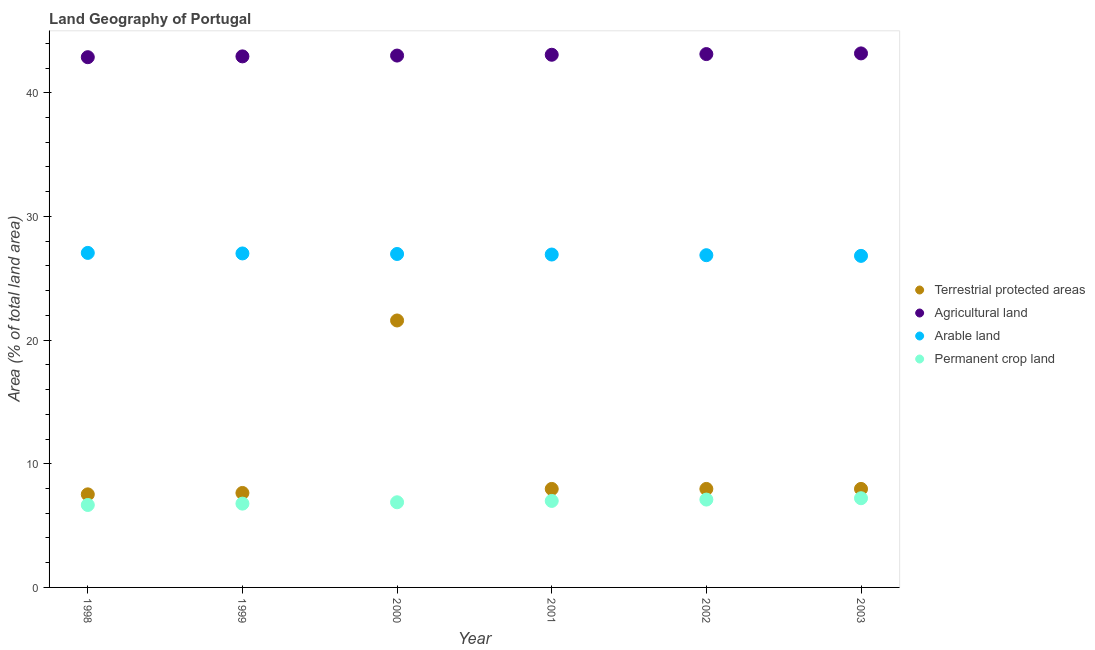Is the number of dotlines equal to the number of legend labels?
Ensure brevity in your answer.  Yes. What is the percentage of area under arable land in 1999?
Keep it short and to the point. 27.01. Across all years, what is the maximum percentage of area under permanent crop land?
Your response must be concise. 7.21. Across all years, what is the minimum percentage of land under terrestrial protection?
Provide a short and direct response. 7.53. In which year was the percentage of area under agricultural land minimum?
Keep it short and to the point. 1998. What is the total percentage of area under agricultural land in the graph?
Provide a succinct answer. 258.2. What is the difference between the percentage of land under terrestrial protection in 1998 and that in 2002?
Provide a succinct answer. -0.44. What is the difference between the percentage of area under permanent crop land in 1999 and the percentage of land under terrestrial protection in 2000?
Your answer should be very brief. -14.81. What is the average percentage of area under permanent crop land per year?
Offer a terse response. 6.94. In the year 2001, what is the difference between the percentage of area under agricultural land and percentage of area under arable land?
Your response must be concise. 16.15. What is the ratio of the percentage of area under agricultural land in 1998 to that in 1999?
Make the answer very short. 1. Is the percentage of area under agricultural land in 2000 less than that in 2002?
Offer a terse response. Yes. What is the difference between the highest and the second highest percentage of area under arable land?
Your response must be concise. 0.04. What is the difference between the highest and the lowest percentage of area under agricultural land?
Provide a short and direct response. 0.31. Is the sum of the percentage of area under permanent crop land in 1999 and 2002 greater than the maximum percentage of area under agricultural land across all years?
Your answer should be very brief. No. Is it the case that in every year, the sum of the percentage of area under agricultural land and percentage of area under permanent crop land is greater than the sum of percentage of land under terrestrial protection and percentage of area under arable land?
Give a very brief answer. Yes. How many years are there in the graph?
Your answer should be very brief. 6. Are the values on the major ticks of Y-axis written in scientific E-notation?
Your answer should be very brief. No. Does the graph contain any zero values?
Offer a very short reply. No. Does the graph contain grids?
Offer a very short reply. No. Where does the legend appear in the graph?
Give a very brief answer. Center right. How many legend labels are there?
Your answer should be very brief. 4. How are the legend labels stacked?
Your answer should be very brief. Vertical. What is the title of the graph?
Your answer should be very brief. Land Geography of Portugal. What is the label or title of the Y-axis?
Your response must be concise. Area (% of total land area). What is the Area (% of total land area) in Terrestrial protected areas in 1998?
Keep it short and to the point. 7.53. What is the Area (% of total land area) of Agricultural land in 1998?
Ensure brevity in your answer.  42.87. What is the Area (% of total land area) of Arable land in 1998?
Offer a terse response. 27.05. What is the Area (% of total land area) in Permanent crop land in 1998?
Ensure brevity in your answer.  6.67. What is the Area (% of total land area) in Terrestrial protected areas in 1999?
Ensure brevity in your answer.  7.64. What is the Area (% of total land area) of Agricultural land in 1999?
Give a very brief answer. 42.94. What is the Area (% of total land area) in Arable land in 1999?
Offer a very short reply. 27.01. What is the Area (% of total land area) of Permanent crop land in 1999?
Your response must be concise. 6.78. What is the Area (% of total land area) of Terrestrial protected areas in 2000?
Offer a very short reply. 21.59. What is the Area (% of total land area) in Agricultural land in 2000?
Make the answer very short. 43.01. What is the Area (% of total land area) of Arable land in 2000?
Provide a succinct answer. 26.96. What is the Area (% of total land area) in Permanent crop land in 2000?
Offer a very short reply. 6.89. What is the Area (% of total land area) in Terrestrial protected areas in 2001?
Your answer should be compact. 7.96. What is the Area (% of total land area) in Agricultural land in 2001?
Give a very brief answer. 43.07. What is the Area (% of total land area) in Arable land in 2001?
Provide a succinct answer. 26.92. What is the Area (% of total land area) in Permanent crop land in 2001?
Your answer should be compact. 6.99. What is the Area (% of total land area) in Terrestrial protected areas in 2002?
Offer a terse response. 7.96. What is the Area (% of total land area) of Agricultural land in 2002?
Offer a very short reply. 43.13. What is the Area (% of total land area) in Arable land in 2002?
Your answer should be compact. 26.86. What is the Area (% of total land area) of Permanent crop land in 2002?
Make the answer very short. 7.1. What is the Area (% of total land area) of Terrestrial protected areas in 2003?
Provide a succinct answer. 7.96. What is the Area (% of total land area) of Agricultural land in 2003?
Provide a short and direct response. 43.18. What is the Area (% of total land area) of Arable land in 2003?
Your answer should be very brief. 26.81. What is the Area (% of total land area) of Permanent crop land in 2003?
Give a very brief answer. 7.21. Across all years, what is the maximum Area (% of total land area) of Terrestrial protected areas?
Make the answer very short. 21.59. Across all years, what is the maximum Area (% of total land area) in Agricultural land?
Keep it short and to the point. 43.18. Across all years, what is the maximum Area (% of total land area) in Arable land?
Offer a very short reply. 27.05. Across all years, what is the maximum Area (% of total land area) in Permanent crop land?
Make the answer very short. 7.21. Across all years, what is the minimum Area (% of total land area) in Terrestrial protected areas?
Your response must be concise. 7.53. Across all years, what is the minimum Area (% of total land area) in Agricultural land?
Keep it short and to the point. 42.87. Across all years, what is the minimum Area (% of total land area) in Arable land?
Provide a short and direct response. 26.81. Across all years, what is the minimum Area (% of total land area) in Permanent crop land?
Your answer should be compact. 6.67. What is the total Area (% of total land area) in Terrestrial protected areas in the graph?
Give a very brief answer. 60.64. What is the total Area (% of total land area) in Agricultural land in the graph?
Make the answer very short. 258.2. What is the total Area (% of total land area) in Arable land in the graph?
Give a very brief answer. 161.61. What is the total Area (% of total land area) of Permanent crop land in the graph?
Your response must be concise. 41.64. What is the difference between the Area (% of total land area) of Terrestrial protected areas in 1998 and that in 1999?
Make the answer very short. -0.11. What is the difference between the Area (% of total land area) in Agricultural land in 1998 and that in 1999?
Your answer should be very brief. -0.07. What is the difference between the Area (% of total land area) in Arable land in 1998 and that in 1999?
Provide a short and direct response. 0.04. What is the difference between the Area (% of total land area) in Permanent crop land in 1998 and that in 1999?
Offer a very short reply. -0.11. What is the difference between the Area (% of total land area) in Terrestrial protected areas in 1998 and that in 2000?
Give a very brief answer. -14.06. What is the difference between the Area (% of total land area) in Agricultural land in 1998 and that in 2000?
Make the answer very short. -0.13. What is the difference between the Area (% of total land area) in Arable land in 1998 and that in 2000?
Make the answer very short. 0.09. What is the difference between the Area (% of total land area) of Permanent crop land in 1998 and that in 2000?
Offer a very short reply. -0.22. What is the difference between the Area (% of total land area) of Terrestrial protected areas in 1998 and that in 2001?
Your response must be concise. -0.44. What is the difference between the Area (% of total land area) in Agricultural land in 1998 and that in 2001?
Provide a succinct answer. -0.2. What is the difference between the Area (% of total land area) of Arable land in 1998 and that in 2001?
Keep it short and to the point. 0.13. What is the difference between the Area (% of total land area) in Permanent crop land in 1998 and that in 2001?
Your answer should be compact. -0.33. What is the difference between the Area (% of total land area) in Terrestrial protected areas in 1998 and that in 2002?
Keep it short and to the point. -0.44. What is the difference between the Area (% of total land area) of Agricultural land in 1998 and that in 2002?
Provide a short and direct response. -0.25. What is the difference between the Area (% of total land area) of Arable land in 1998 and that in 2002?
Keep it short and to the point. 0.19. What is the difference between the Area (% of total land area) of Permanent crop land in 1998 and that in 2002?
Provide a succinct answer. -0.44. What is the difference between the Area (% of total land area) of Terrestrial protected areas in 1998 and that in 2003?
Your answer should be compact. -0.44. What is the difference between the Area (% of total land area) of Agricultural land in 1998 and that in 2003?
Provide a succinct answer. -0.31. What is the difference between the Area (% of total land area) in Arable land in 1998 and that in 2003?
Keep it short and to the point. 0.24. What is the difference between the Area (% of total land area) of Permanent crop land in 1998 and that in 2003?
Ensure brevity in your answer.  -0.55. What is the difference between the Area (% of total land area) in Terrestrial protected areas in 1999 and that in 2000?
Make the answer very short. -13.95. What is the difference between the Area (% of total land area) in Agricultural land in 1999 and that in 2000?
Provide a succinct answer. -0.07. What is the difference between the Area (% of total land area) in Arable land in 1999 and that in 2000?
Offer a very short reply. 0.04. What is the difference between the Area (% of total land area) of Permanent crop land in 1999 and that in 2000?
Ensure brevity in your answer.  -0.11. What is the difference between the Area (% of total land area) in Terrestrial protected areas in 1999 and that in 2001?
Offer a terse response. -0.33. What is the difference between the Area (% of total land area) in Agricultural land in 1999 and that in 2001?
Give a very brief answer. -0.13. What is the difference between the Area (% of total land area) in Arable land in 1999 and that in 2001?
Offer a terse response. 0.09. What is the difference between the Area (% of total land area) in Permanent crop land in 1999 and that in 2001?
Your answer should be very brief. -0.22. What is the difference between the Area (% of total land area) in Terrestrial protected areas in 1999 and that in 2002?
Offer a very short reply. -0.33. What is the difference between the Area (% of total land area) in Agricultural land in 1999 and that in 2002?
Make the answer very short. -0.19. What is the difference between the Area (% of total land area) of Arable land in 1999 and that in 2002?
Provide a succinct answer. 0.14. What is the difference between the Area (% of total land area) of Permanent crop land in 1999 and that in 2002?
Provide a succinct answer. -0.33. What is the difference between the Area (% of total land area) of Terrestrial protected areas in 1999 and that in 2003?
Your response must be concise. -0.33. What is the difference between the Area (% of total land area) of Agricultural land in 1999 and that in 2003?
Provide a short and direct response. -0.24. What is the difference between the Area (% of total land area) in Arable land in 1999 and that in 2003?
Provide a succinct answer. 0.2. What is the difference between the Area (% of total land area) in Permanent crop land in 1999 and that in 2003?
Offer a terse response. -0.44. What is the difference between the Area (% of total land area) of Terrestrial protected areas in 2000 and that in 2001?
Keep it short and to the point. 13.62. What is the difference between the Area (% of total land area) of Agricultural land in 2000 and that in 2001?
Offer a terse response. -0.07. What is the difference between the Area (% of total land area) of Arable land in 2000 and that in 2001?
Give a very brief answer. 0.04. What is the difference between the Area (% of total land area) in Permanent crop land in 2000 and that in 2001?
Your answer should be compact. -0.11. What is the difference between the Area (% of total land area) of Terrestrial protected areas in 2000 and that in 2002?
Offer a terse response. 13.62. What is the difference between the Area (% of total land area) of Agricultural land in 2000 and that in 2002?
Your answer should be very brief. -0.12. What is the difference between the Area (% of total land area) in Arable land in 2000 and that in 2002?
Make the answer very short. 0.1. What is the difference between the Area (% of total land area) in Permanent crop land in 2000 and that in 2002?
Provide a short and direct response. -0.22. What is the difference between the Area (% of total land area) in Terrestrial protected areas in 2000 and that in 2003?
Ensure brevity in your answer.  13.62. What is the difference between the Area (% of total land area) in Agricultural land in 2000 and that in 2003?
Your answer should be compact. -0.17. What is the difference between the Area (% of total land area) of Arable land in 2000 and that in 2003?
Provide a succinct answer. 0.15. What is the difference between the Area (% of total land area) in Permanent crop land in 2000 and that in 2003?
Keep it short and to the point. -0.33. What is the difference between the Area (% of total land area) in Terrestrial protected areas in 2001 and that in 2002?
Your answer should be very brief. 0. What is the difference between the Area (% of total land area) of Agricultural land in 2001 and that in 2002?
Provide a succinct answer. -0.05. What is the difference between the Area (% of total land area) of Arable land in 2001 and that in 2002?
Ensure brevity in your answer.  0.05. What is the difference between the Area (% of total land area) in Permanent crop land in 2001 and that in 2002?
Ensure brevity in your answer.  -0.11. What is the difference between the Area (% of total land area) of Agricultural land in 2001 and that in 2003?
Your answer should be compact. -0.11. What is the difference between the Area (% of total land area) of Arable land in 2001 and that in 2003?
Offer a very short reply. 0.11. What is the difference between the Area (% of total land area) in Permanent crop land in 2001 and that in 2003?
Make the answer very short. -0.22. What is the difference between the Area (% of total land area) of Terrestrial protected areas in 2002 and that in 2003?
Give a very brief answer. 0. What is the difference between the Area (% of total land area) in Agricultural land in 2002 and that in 2003?
Keep it short and to the point. -0.05. What is the difference between the Area (% of total land area) in Arable land in 2002 and that in 2003?
Provide a short and direct response. 0.05. What is the difference between the Area (% of total land area) of Permanent crop land in 2002 and that in 2003?
Keep it short and to the point. -0.11. What is the difference between the Area (% of total land area) in Terrestrial protected areas in 1998 and the Area (% of total land area) in Agricultural land in 1999?
Your answer should be very brief. -35.41. What is the difference between the Area (% of total land area) of Terrestrial protected areas in 1998 and the Area (% of total land area) of Arable land in 1999?
Make the answer very short. -19.48. What is the difference between the Area (% of total land area) of Terrestrial protected areas in 1998 and the Area (% of total land area) of Permanent crop land in 1999?
Provide a succinct answer. 0.75. What is the difference between the Area (% of total land area) in Agricultural land in 1998 and the Area (% of total land area) in Arable land in 1999?
Ensure brevity in your answer.  15.87. What is the difference between the Area (% of total land area) in Agricultural land in 1998 and the Area (% of total land area) in Permanent crop land in 1999?
Keep it short and to the point. 36.1. What is the difference between the Area (% of total land area) in Arable land in 1998 and the Area (% of total land area) in Permanent crop land in 1999?
Your answer should be compact. 20.27. What is the difference between the Area (% of total land area) of Terrestrial protected areas in 1998 and the Area (% of total land area) of Agricultural land in 2000?
Your answer should be compact. -35.48. What is the difference between the Area (% of total land area) in Terrestrial protected areas in 1998 and the Area (% of total land area) in Arable land in 2000?
Your response must be concise. -19.44. What is the difference between the Area (% of total land area) in Terrestrial protected areas in 1998 and the Area (% of total land area) in Permanent crop land in 2000?
Provide a short and direct response. 0.64. What is the difference between the Area (% of total land area) of Agricultural land in 1998 and the Area (% of total land area) of Arable land in 2000?
Your answer should be very brief. 15.91. What is the difference between the Area (% of total land area) of Agricultural land in 1998 and the Area (% of total land area) of Permanent crop land in 2000?
Provide a succinct answer. 35.99. What is the difference between the Area (% of total land area) in Arable land in 1998 and the Area (% of total land area) in Permanent crop land in 2000?
Your answer should be compact. 20.16. What is the difference between the Area (% of total land area) in Terrestrial protected areas in 1998 and the Area (% of total land area) in Agricultural land in 2001?
Provide a short and direct response. -35.55. What is the difference between the Area (% of total land area) in Terrestrial protected areas in 1998 and the Area (% of total land area) in Arable land in 2001?
Make the answer very short. -19.39. What is the difference between the Area (% of total land area) of Terrestrial protected areas in 1998 and the Area (% of total land area) of Permanent crop land in 2001?
Provide a succinct answer. 0.53. What is the difference between the Area (% of total land area) in Agricultural land in 1998 and the Area (% of total land area) in Arable land in 2001?
Give a very brief answer. 15.96. What is the difference between the Area (% of total land area) in Agricultural land in 1998 and the Area (% of total land area) in Permanent crop land in 2001?
Keep it short and to the point. 35.88. What is the difference between the Area (% of total land area) of Arable land in 1998 and the Area (% of total land area) of Permanent crop land in 2001?
Keep it short and to the point. 20.05. What is the difference between the Area (% of total land area) in Terrestrial protected areas in 1998 and the Area (% of total land area) in Agricultural land in 2002?
Keep it short and to the point. -35.6. What is the difference between the Area (% of total land area) in Terrestrial protected areas in 1998 and the Area (% of total land area) in Arable land in 2002?
Keep it short and to the point. -19.34. What is the difference between the Area (% of total land area) in Terrestrial protected areas in 1998 and the Area (% of total land area) in Permanent crop land in 2002?
Your answer should be compact. 0.42. What is the difference between the Area (% of total land area) of Agricultural land in 1998 and the Area (% of total land area) of Arable land in 2002?
Your answer should be very brief. 16.01. What is the difference between the Area (% of total land area) in Agricultural land in 1998 and the Area (% of total land area) in Permanent crop land in 2002?
Offer a terse response. 35.77. What is the difference between the Area (% of total land area) in Arable land in 1998 and the Area (% of total land area) in Permanent crop land in 2002?
Make the answer very short. 19.95. What is the difference between the Area (% of total land area) in Terrestrial protected areas in 1998 and the Area (% of total land area) in Agricultural land in 2003?
Keep it short and to the point. -35.65. What is the difference between the Area (% of total land area) of Terrestrial protected areas in 1998 and the Area (% of total land area) of Arable land in 2003?
Make the answer very short. -19.28. What is the difference between the Area (% of total land area) in Terrestrial protected areas in 1998 and the Area (% of total land area) in Permanent crop land in 2003?
Ensure brevity in your answer.  0.31. What is the difference between the Area (% of total land area) in Agricultural land in 1998 and the Area (% of total land area) in Arable land in 2003?
Make the answer very short. 16.07. What is the difference between the Area (% of total land area) in Agricultural land in 1998 and the Area (% of total land area) in Permanent crop land in 2003?
Make the answer very short. 35.66. What is the difference between the Area (% of total land area) of Arable land in 1998 and the Area (% of total land area) of Permanent crop land in 2003?
Provide a succinct answer. 19.84. What is the difference between the Area (% of total land area) in Terrestrial protected areas in 1999 and the Area (% of total land area) in Agricultural land in 2000?
Offer a very short reply. -35.37. What is the difference between the Area (% of total land area) in Terrestrial protected areas in 1999 and the Area (% of total land area) in Arable land in 2000?
Provide a succinct answer. -19.32. What is the difference between the Area (% of total land area) of Terrestrial protected areas in 1999 and the Area (% of total land area) of Permanent crop land in 2000?
Keep it short and to the point. 0.75. What is the difference between the Area (% of total land area) in Agricultural land in 1999 and the Area (% of total land area) in Arable land in 2000?
Provide a succinct answer. 15.98. What is the difference between the Area (% of total land area) of Agricultural land in 1999 and the Area (% of total land area) of Permanent crop land in 2000?
Ensure brevity in your answer.  36.05. What is the difference between the Area (% of total land area) of Arable land in 1999 and the Area (% of total land area) of Permanent crop land in 2000?
Make the answer very short. 20.12. What is the difference between the Area (% of total land area) of Terrestrial protected areas in 1999 and the Area (% of total land area) of Agricultural land in 2001?
Provide a succinct answer. -35.43. What is the difference between the Area (% of total land area) of Terrestrial protected areas in 1999 and the Area (% of total land area) of Arable land in 2001?
Offer a terse response. -19.28. What is the difference between the Area (% of total land area) in Terrestrial protected areas in 1999 and the Area (% of total land area) in Permanent crop land in 2001?
Provide a succinct answer. 0.64. What is the difference between the Area (% of total land area) in Agricultural land in 1999 and the Area (% of total land area) in Arable land in 2001?
Offer a terse response. 16.02. What is the difference between the Area (% of total land area) in Agricultural land in 1999 and the Area (% of total land area) in Permanent crop land in 2001?
Give a very brief answer. 35.95. What is the difference between the Area (% of total land area) in Arable land in 1999 and the Area (% of total land area) in Permanent crop land in 2001?
Your answer should be very brief. 20.01. What is the difference between the Area (% of total land area) in Terrestrial protected areas in 1999 and the Area (% of total land area) in Agricultural land in 2002?
Your answer should be compact. -35.49. What is the difference between the Area (% of total land area) of Terrestrial protected areas in 1999 and the Area (% of total land area) of Arable land in 2002?
Give a very brief answer. -19.23. What is the difference between the Area (% of total land area) of Terrestrial protected areas in 1999 and the Area (% of total land area) of Permanent crop land in 2002?
Ensure brevity in your answer.  0.53. What is the difference between the Area (% of total land area) of Agricultural land in 1999 and the Area (% of total land area) of Arable land in 2002?
Keep it short and to the point. 16.08. What is the difference between the Area (% of total land area) of Agricultural land in 1999 and the Area (% of total land area) of Permanent crop land in 2002?
Give a very brief answer. 35.84. What is the difference between the Area (% of total land area) of Arable land in 1999 and the Area (% of total land area) of Permanent crop land in 2002?
Your answer should be very brief. 19.9. What is the difference between the Area (% of total land area) of Terrestrial protected areas in 1999 and the Area (% of total land area) of Agricultural land in 2003?
Your response must be concise. -35.54. What is the difference between the Area (% of total land area) in Terrestrial protected areas in 1999 and the Area (% of total land area) in Arable land in 2003?
Your answer should be very brief. -19.17. What is the difference between the Area (% of total land area) in Terrestrial protected areas in 1999 and the Area (% of total land area) in Permanent crop land in 2003?
Keep it short and to the point. 0.43. What is the difference between the Area (% of total land area) of Agricultural land in 1999 and the Area (% of total land area) of Arable land in 2003?
Your answer should be compact. 16.13. What is the difference between the Area (% of total land area) of Agricultural land in 1999 and the Area (% of total land area) of Permanent crop land in 2003?
Provide a short and direct response. 35.73. What is the difference between the Area (% of total land area) of Arable land in 1999 and the Area (% of total land area) of Permanent crop land in 2003?
Make the answer very short. 19.79. What is the difference between the Area (% of total land area) in Terrestrial protected areas in 2000 and the Area (% of total land area) in Agricultural land in 2001?
Your answer should be compact. -21.49. What is the difference between the Area (% of total land area) of Terrestrial protected areas in 2000 and the Area (% of total land area) of Arable land in 2001?
Give a very brief answer. -5.33. What is the difference between the Area (% of total land area) of Terrestrial protected areas in 2000 and the Area (% of total land area) of Permanent crop land in 2001?
Your response must be concise. 14.59. What is the difference between the Area (% of total land area) of Agricultural land in 2000 and the Area (% of total land area) of Arable land in 2001?
Your answer should be very brief. 16.09. What is the difference between the Area (% of total land area) of Agricultural land in 2000 and the Area (% of total land area) of Permanent crop land in 2001?
Provide a succinct answer. 36.01. What is the difference between the Area (% of total land area) of Arable land in 2000 and the Area (% of total land area) of Permanent crop land in 2001?
Your response must be concise. 19.97. What is the difference between the Area (% of total land area) of Terrestrial protected areas in 2000 and the Area (% of total land area) of Agricultural land in 2002?
Offer a very short reply. -21.54. What is the difference between the Area (% of total land area) in Terrestrial protected areas in 2000 and the Area (% of total land area) in Arable land in 2002?
Make the answer very short. -5.28. What is the difference between the Area (% of total land area) in Terrestrial protected areas in 2000 and the Area (% of total land area) in Permanent crop land in 2002?
Provide a succinct answer. 14.48. What is the difference between the Area (% of total land area) of Agricultural land in 2000 and the Area (% of total land area) of Arable land in 2002?
Offer a terse response. 16.14. What is the difference between the Area (% of total land area) in Agricultural land in 2000 and the Area (% of total land area) in Permanent crop land in 2002?
Your response must be concise. 35.9. What is the difference between the Area (% of total land area) in Arable land in 2000 and the Area (% of total land area) in Permanent crop land in 2002?
Your response must be concise. 19.86. What is the difference between the Area (% of total land area) of Terrestrial protected areas in 2000 and the Area (% of total land area) of Agricultural land in 2003?
Provide a short and direct response. -21.59. What is the difference between the Area (% of total land area) of Terrestrial protected areas in 2000 and the Area (% of total land area) of Arable land in 2003?
Ensure brevity in your answer.  -5.22. What is the difference between the Area (% of total land area) of Terrestrial protected areas in 2000 and the Area (% of total land area) of Permanent crop land in 2003?
Make the answer very short. 14.37. What is the difference between the Area (% of total land area) in Agricultural land in 2000 and the Area (% of total land area) in Arable land in 2003?
Your answer should be very brief. 16.2. What is the difference between the Area (% of total land area) of Agricultural land in 2000 and the Area (% of total land area) of Permanent crop land in 2003?
Provide a short and direct response. 35.79. What is the difference between the Area (% of total land area) of Arable land in 2000 and the Area (% of total land area) of Permanent crop land in 2003?
Give a very brief answer. 19.75. What is the difference between the Area (% of total land area) of Terrestrial protected areas in 2001 and the Area (% of total land area) of Agricultural land in 2002?
Provide a succinct answer. -35.16. What is the difference between the Area (% of total land area) in Terrestrial protected areas in 2001 and the Area (% of total land area) in Arable land in 2002?
Make the answer very short. -18.9. What is the difference between the Area (% of total land area) of Terrestrial protected areas in 2001 and the Area (% of total land area) of Permanent crop land in 2002?
Offer a very short reply. 0.86. What is the difference between the Area (% of total land area) in Agricultural land in 2001 and the Area (% of total land area) in Arable land in 2002?
Keep it short and to the point. 16.21. What is the difference between the Area (% of total land area) in Agricultural land in 2001 and the Area (% of total land area) in Permanent crop land in 2002?
Offer a very short reply. 35.97. What is the difference between the Area (% of total land area) of Arable land in 2001 and the Area (% of total land area) of Permanent crop land in 2002?
Offer a terse response. 19.81. What is the difference between the Area (% of total land area) in Terrestrial protected areas in 2001 and the Area (% of total land area) in Agricultural land in 2003?
Give a very brief answer. -35.22. What is the difference between the Area (% of total land area) in Terrestrial protected areas in 2001 and the Area (% of total land area) in Arable land in 2003?
Make the answer very short. -18.84. What is the difference between the Area (% of total land area) of Terrestrial protected areas in 2001 and the Area (% of total land area) of Permanent crop land in 2003?
Give a very brief answer. 0.75. What is the difference between the Area (% of total land area) in Agricultural land in 2001 and the Area (% of total land area) in Arable land in 2003?
Offer a terse response. 16.26. What is the difference between the Area (% of total land area) in Agricultural land in 2001 and the Area (% of total land area) in Permanent crop land in 2003?
Keep it short and to the point. 35.86. What is the difference between the Area (% of total land area) in Arable land in 2001 and the Area (% of total land area) in Permanent crop land in 2003?
Give a very brief answer. 19.7. What is the difference between the Area (% of total land area) of Terrestrial protected areas in 2002 and the Area (% of total land area) of Agricultural land in 2003?
Provide a short and direct response. -35.22. What is the difference between the Area (% of total land area) in Terrestrial protected areas in 2002 and the Area (% of total land area) in Arable land in 2003?
Make the answer very short. -18.84. What is the difference between the Area (% of total land area) of Terrestrial protected areas in 2002 and the Area (% of total land area) of Permanent crop land in 2003?
Make the answer very short. 0.75. What is the difference between the Area (% of total land area) in Agricultural land in 2002 and the Area (% of total land area) in Arable land in 2003?
Offer a terse response. 16.32. What is the difference between the Area (% of total land area) of Agricultural land in 2002 and the Area (% of total land area) of Permanent crop land in 2003?
Provide a short and direct response. 35.91. What is the difference between the Area (% of total land area) in Arable land in 2002 and the Area (% of total land area) in Permanent crop land in 2003?
Offer a terse response. 19.65. What is the average Area (% of total land area) in Terrestrial protected areas per year?
Give a very brief answer. 10.11. What is the average Area (% of total land area) in Agricultural land per year?
Offer a terse response. 43.03. What is the average Area (% of total land area) of Arable land per year?
Offer a terse response. 26.93. What is the average Area (% of total land area) of Permanent crop land per year?
Provide a succinct answer. 6.94. In the year 1998, what is the difference between the Area (% of total land area) of Terrestrial protected areas and Area (% of total land area) of Agricultural land?
Give a very brief answer. -35.35. In the year 1998, what is the difference between the Area (% of total land area) of Terrestrial protected areas and Area (% of total land area) of Arable land?
Ensure brevity in your answer.  -19.52. In the year 1998, what is the difference between the Area (% of total land area) of Terrestrial protected areas and Area (% of total land area) of Permanent crop land?
Provide a short and direct response. 0.86. In the year 1998, what is the difference between the Area (% of total land area) of Agricultural land and Area (% of total land area) of Arable land?
Your response must be concise. 15.83. In the year 1998, what is the difference between the Area (% of total land area) of Agricultural land and Area (% of total land area) of Permanent crop land?
Offer a terse response. 36.21. In the year 1998, what is the difference between the Area (% of total land area) of Arable land and Area (% of total land area) of Permanent crop land?
Your response must be concise. 20.38. In the year 1999, what is the difference between the Area (% of total land area) in Terrestrial protected areas and Area (% of total land area) in Agricultural land?
Keep it short and to the point. -35.3. In the year 1999, what is the difference between the Area (% of total land area) of Terrestrial protected areas and Area (% of total land area) of Arable land?
Give a very brief answer. -19.37. In the year 1999, what is the difference between the Area (% of total land area) in Terrestrial protected areas and Area (% of total land area) in Permanent crop land?
Keep it short and to the point. 0.86. In the year 1999, what is the difference between the Area (% of total land area) in Agricultural land and Area (% of total land area) in Arable land?
Ensure brevity in your answer.  15.93. In the year 1999, what is the difference between the Area (% of total land area) of Agricultural land and Area (% of total land area) of Permanent crop land?
Give a very brief answer. 36.16. In the year 1999, what is the difference between the Area (% of total land area) of Arable land and Area (% of total land area) of Permanent crop land?
Provide a succinct answer. 20.23. In the year 2000, what is the difference between the Area (% of total land area) of Terrestrial protected areas and Area (% of total land area) of Agricultural land?
Offer a terse response. -21.42. In the year 2000, what is the difference between the Area (% of total land area) of Terrestrial protected areas and Area (% of total land area) of Arable land?
Provide a short and direct response. -5.38. In the year 2000, what is the difference between the Area (% of total land area) in Terrestrial protected areas and Area (% of total land area) in Permanent crop land?
Keep it short and to the point. 14.7. In the year 2000, what is the difference between the Area (% of total land area) in Agricultural land and Area (% of total land area) in Arable land?
Offer a terse response. 16.04. In the year 2000, what is the difference between the Area (% of total land area) in Agricultural land and Area (% of total land area) in Permanent crop land?
Ensure brevity in your answer.  36.12. In the year 2000, what is the difference between the Area (% of total land area) in Arable land and Area (% of total land area) in Permanent crop land?
Provide a succinct answer. 20.08. In the year 2001, what is the difference between the Area (% of total land area) in Terrestrial protected areas and Area (% of total land area) in Agricultural land?
Keep it short and to the point. -35.11. In the year 2001, what is the difference between the Area (% of total land area) of Terrestrial protected areas and Area (% of total land area) of Arable land?
Your answer should be very brief. -18.95. In the year 2001, what is the difference between the Area (% of total land area) of Terrestrial protected areas and Area (% of total land area) of Permanent crop land?
Offer a terse response. 0.97. In the year 2001, what is the difference between the Area (% of total land area) of Agricultural land and Area (% of total land area) of Arable land?
Your answer should be very brief. 16.15. In the year 2001, what is the difference between the Area (% of total land area) of Agricultural land and Area (% of total land area) of Permanent crop land?
Provide a succinct answer. 36.08. In the year 2001, what is the difference between the Area (% of total land area) of Arable land and Area (% of total land area) of Permanent crop land?
Ensure brevity in your answer.  19.92. In the year 2002, what is the difference between the Area (% of total land area) in Terrestrial protected areas and Area (% of total land area) in Agricultural land?
Make the answer very short. -35.16. In the year 2002, what is the difference between the Area (% of total land area) of Terrestrial protected areas and Area (% of total land area) of Arable land?
Your answer should be very brief. -18.9. In the year 2002, what is the difference between the Area (% of total land area) of Terrestrial protected areas and Area (% of total land area) of Permanent crop land?
Give a very brief answer. 0.86. In the year 2002, what is the difference between the Area (% of total land area) of Agricultural land and Area (% of total land area) of Arable land?
Make the answer very short. 16.26. In the year 2002, what is the difference between the Area (% of total land area) of Agricultural land and Area (% of total land area) of Permanent crop land?
Your response must be concise. 36.02. In the year 2002, what is the difference between the Area (% of total land area) of Arable land and Area (% of total land area) of Permanent crop land?
Offer a very short reply. 19.76. In the year 2003, what is the difference between the Area (% of total land area) of Terrestrial protected areas and Area (% of total land area) of Agricultural land?
Offer a terse response. -35.22. In the year 2003, what is the difference between the Area (% of total land area) of Terrestrial protected areas and Area (% of total land area) of Arable land?
Your answer should be very brief. -18.84. In the year 2003, what is the difference between the Area (% of total land area) in Terrestrial protected areas and Area (% of total land area) in Permanent crop land?
Give a very brief answer. 0.75. In the year 2003, what is the difference between the Area (% of total land area) in Agricultural land and Area (% of total land area) in Arable land?
Your response must be concise. 16.37. In the year 2003, what is the difference between the Area (% of total land area) of Agricultural land and Area (% of total land area) of Permanent crop land?
Ensure brevity in your answer.  35.97. In the year 2003, what is the difference between the Area (% of total land area) of Arable land and Area (% of total land area) of Permanent crop land?
Keep it short and to the point. 19.6. What is the ratio of the Area (% of total land area) in Terrestrial protected areas in 1998 to that in 1999?
Offer a very short reply. 0.99. What is the ratio of the Area (% of total land area) in Agricultural land in 1998 to that in 1999?
Provide a succinct answer. 1. What is the ratio of the Area (% of total land area) in Arable land in 1998 to that in 1999?
Ensure brevity in your answer.  1. What is the ratio of the Area (% of total land area) of Permanent crop land in 1998 to that in 1999?
Your response must be concise. 0.98. What is the ratio of the Area (% of total land area) in Terrestrial protected areas in 1998 to that in 2000?
Make the answer very short. 0.35. What is the ratio of the Area (% of total land area) in Arable land in 1998 to that in 2000?
Your answer should be very brief. 1. What is the ratio of the Area (% of total land area) in Permanent crop land in 1998 to that in 2000?
Your response must be concise. 0.97. What is the ratio of the Area (% of total land area) of Terrestrial protected areas in 1998 to that in 2001?
Keep it short and to the point. 0.94. What is the ratio of the Area (% of total land area) in Agricultural land in 1998 to that in 2001?
Make the answer very short. 1. What is the ratio of the Area (% of total land area) in Permanent crop land in 1998 to that in 2001?
Provide a succinct answer. 0.95. What is the ratio of the Area (% of total land area) of Terrestrial protected areas in 1998 to that in 2002?
Provide a succinct answer. 0.94. What is the ratio of the Area (% of total land area) of Arable land in 1998 to that in 2002?
Offer a very short reply. 1.01. What is the ratio of the Area (% of total land area) in Permanent crop land in 1998 to that in 2002?
Provide a short and direct response. 0.94. What is the ratio of the Area (% of total land area) in Terrestrial protected areas in 1998 to that in 2003?
Keep it short and to the point. 0.94. What is the ratio of the Area (% of total land area) in Arable land in 1998 to that in 2003?
Offer a very short reply. 1.01. What is the ratio of the Area (% of total land area) of Permanent crop land in 1998 to that in 2003?
Offer a terse response. 0.92. What is the ratio of the Area (% of total land area) in Terrestrial protected areas in 1999 to that in 2000?
Make the answer very short. 0.35. What is the ratio of the Area (% of total land area) of Agricultural land in 1999 to that in 2000?
Offer a very short reply. 1. What is the ratio of the Area (% of total land area) of Permanent crop land in 1999 to that in 2000?
Provide a succinct answer. 0.98. What is the ratio of the Area (% of total land area) in Terrestrial protected areas in 1999 to that in 2001?
Keep it short and to the point. 0.96. What is the ratio of the Area (% of total land area) in Agricultural land in 1999 to that in 2001?
Offer a very short reply. 1. What is the ratio of the Area (% of total land area) of Arable land in 1999 to that in 2001?
Ensure brevity in your answer.  1. What is the ratio of the Area (% of total land area) of Permanent crop land in 1999 to that in 2001?
Make the answer very short. 0.97. What is the ratio of the Area (% of total land area) in Agricultural land in 1999 to that in 2002?
Give a very brief answer. 1. What is the ratio of the Area (% of total land area) in Permanent crop land in 1999 to that in 2002?
Make the answer very short. 0.95. What is the ratio of the Area (% of total land area) of Terrestrial protected areas in 1999 to that in 2003?
Make the answer very short. 0.96. What is the ratio of the Area (% of total land area) of Agricultural land in 1999 to that in 2003?
Your answer should be compact. 0.99. What is the ratio of the Area (% of total land area) of Arable land in 1999 to that in 2003?
Make the answer very short. 1.01. What is the ratio of the Area (% of total land area) in Permanent crop land in 1999 to that in 2003?
Offer a terse response. 0.94. What is the ratio of the Area (% of total land area) in Terrestrial protected areas in 2000 to that in 2001?
Give a very brief answer. 2.71. What is the ratio of the Area (% of total land area) of Agricultural land in 2000 to that in 2001?
Make the answer very short. 1. What is the ratio of the Area (% of total land area) in Arable land in 2000 to that in 2001?
Provide a short and direct response. 1. What is the ratio of the Area (% of total land area) of Permanent crop land in 2000 to that in 2001?
Ensure brevity in your answer.  0.98. What is the ratio of the Area (% of total land area) of Terrestrial protected areas in 2000 to that in 2002?
Give a very brief answer. 2.71. What is the ratio of the Area (% of total land area) in Agricultural land in 2000 to that in 2002?
Keep it short and to the point. 1. What is the ratio of the Area (% of total land area) in Permanent crop land in 2000 to that in 2002?
Offer a terse response. 0.97. What is the ratio of the Area (% of total land area) in Terrestrial protected areas in 2000 to that in 2003?
Ensure brevity in your answer.  2.71. What is the ratio of the Area (% of total land area) in Arable land in 2000 to that in 2003?
Ensure brevity in your answer.  1.01. What is the ratio of the Area (% of total land area) of Permanent crop land in 2000 to that in 2003?
Your response must be concise. 0.95. What is the ratio of the Area (% of total land area) in Terrestrial protected areas in 2001 to that in 2002?
Ensure brevity in your answer.  1. What is the ratio of the Area (% of total land area) of Agricultural land in 2001 to that in 2002?
Make the answer very short. 1. What is the ratio of the Area (% of total land area) of Permanent crop land in 2001 to that in 2002?
Your answer should be very brief. 0.98. What is the ratio of the Area (% of total land area) in Terrestrial protected areas in 2001 to that in 2003?
Offer a terse response. 1. What is the ratio of the Area (% of total land area) of Agricultural land in 2001 to that in 2003?
Provide a succinct answer. 1. What is the ratio of the Area (% of total land area) in Arable land in 2001 to that in 2003?
Your response must be concise. 1. What is the ratio of the Area (% of total land area) in Permanent crop land in 2001 to that in 2003?
Ensure brevity in your answer.  0.97. What is the difference between the highest and the second highest Area (% of total land area) of Terrestrial protected areas?
Offer a terse response. 13.62. What is the difference between the highest and the second highest Area (% of total land area) of Agricultural land?
Make the answer very short. 0.05. What is the difference between the highest and the second highest Area (% of total land area) in Arable land?
Your answer should be compact. 0.04. What is the difference between the highest and the second highest Area (% of total land area) of Permanent crop land?
Ensure brevity in your answer.  0.11. What is the difference between the highest and the lowest Area (% of total land area) in Terrestrial protected areas?
Ensure brevity in your answer.  14.06. What is the difference between the highest and the lowest Area (% of total land area) in Agricultural land?
Offer a very short reply. 0.31. What is the difference between the highest and the lowest Area (% of total land area) of Arable land?
Ensure brevity in your answer.  0.24. What is the difference between the highest and the lowest Area (% of total land area) of Permanent crop land?
Make the answer very short. 0.55. 